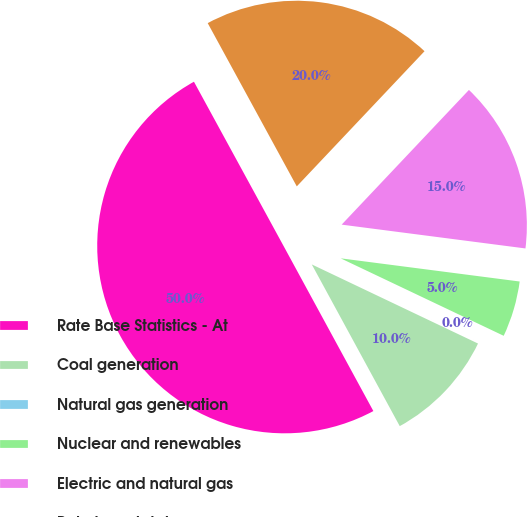<chart> <loc_0><loc_0><loc_500><loc_500><pie_chart><fcel>Rate Base Statistics - At<fcel>Coal generation<fcel>Natural gas generation<fcel>Nuclear and renewables<fcel>Electric and natural gas<fcel>Rate base total<nl><fcel>49.98%<fcel>10.0%<fcel>0.01%<fcel>5.01%<fcel>15.0%<fcel>20.0%<nl></chart> 